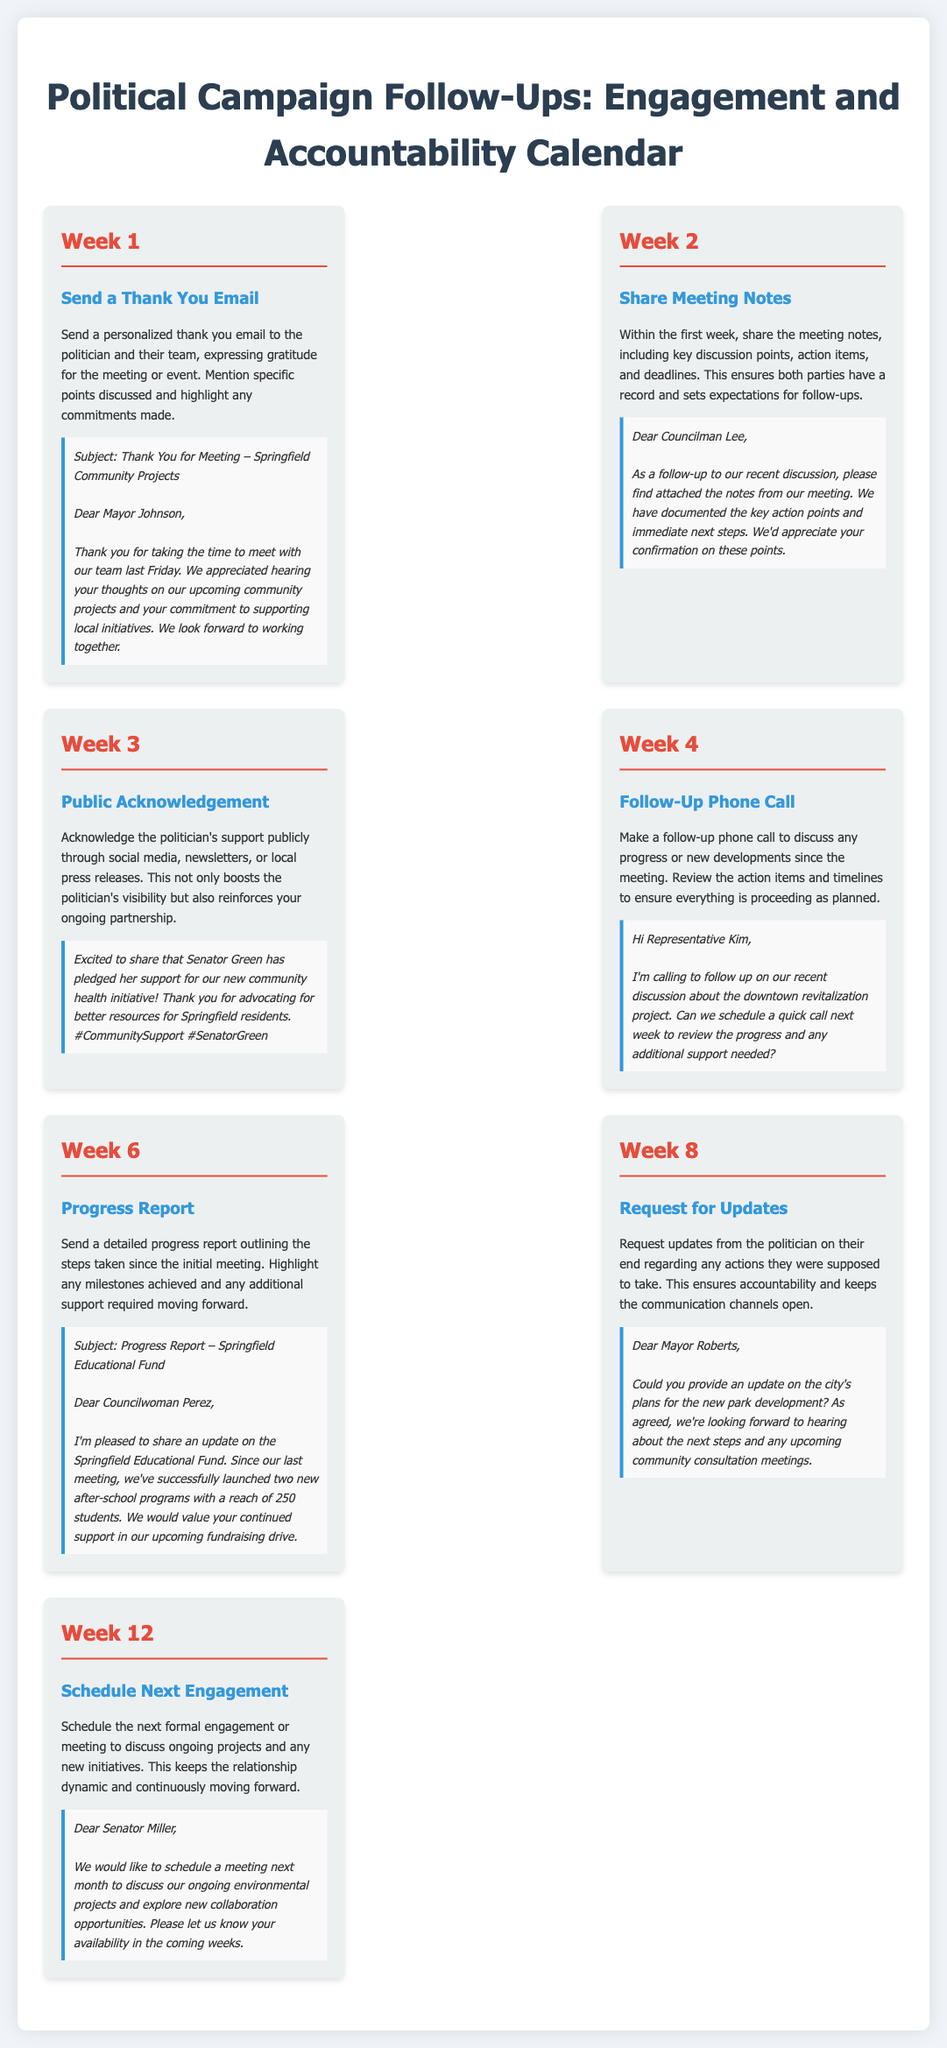What is the first follow-up action listed? The first follow-up action listed is "Send a Thank You Email" in Week 1.
Answer: Send a Thank You Email How long after the meeting should the meeting notes be shared? The meeting notes should be shared within the first week, which corresponds to Week 2 as listed.
Answer: Within the first week What is the subject of the thank you email example? The subject of the thank you email example is "Thank You for Meeting – Springfield Community Projects."
Answer: Thank You for Meeting – Springfield Community Projects What is the follow-up action in Week 6? The follow-up action in Week 6 is sending a "Progress Report."
Answer: Progress Report What key element is highlighted in Week 3's follow-up? The key element highlighted in Week 3's follow-up is public acknowledgment of support through social media, newsletters, or local press releases.
Answer: Public acknowledgment How many weeks after the meeting should a follow-up phone call be made? A follow-up phone call should be made in Week 4, which is three weeks after the meeting.
Answer: Three weeks What type of follow-up action occurs in Week 12? In Week 12, the action is to "Schedule Next Engagement."
Answer: Schedule Next Engagement What specific date is the example correspondence for the progress report addressed? The example correspondence for the progress report is addressed to "Councilwoman Perez."
Answer: Councilwoman Perez What is the example of a follow-up phone call about? The example of a follow-up phone call is about the downtown revitalization project.
Answer: Downtown revitalization project 